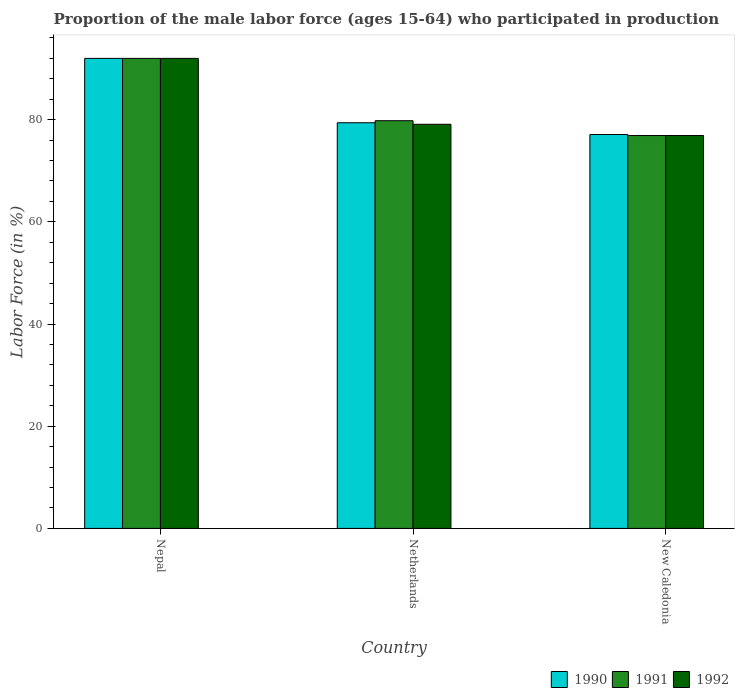What is the label of the 1st group of bars from the left?
Provide a short and direct response. Nepal. What is the proportion of the male labor force who participated in production in 1991 in Netherlands?
Provide a succinct answer. 79.8. Across all countries, what is the maximum proportion of the male labor force who participated in production in 1990?
Provide a succinct answer. 92. Across all countries, what is the minimum proportion of the male labor force who participated in production in 1990?
Provide a short and direct response. 77.1. In which country was the proportion of the male labor force who participated in production in 1991 maximum?
Provide a succinct answer. Nepal. In which country was the proportion of the male labor force who participated in production in 1992 minimum?
Make the answer very short. New Caledonia. What is the total proportion of the male labor force who participated in production in 1991 in the graph?
Ensure brevity in your answer.  248.7. What is the difference between the proportion of the male labor force who participated in production in 1991 in Nepal and that in Netherlands?
Keep it short and to the point. 12.2. What is the difference between the proportion of the male labor force who participated in production in 1992 in Netherlands and the proportion of the male labor force who participated in production in 1991 in New Caledonia?
Your response must be concise. 2.2. What is the average proportion of the male labor force who participated in production in 1992 per country?
Your answer should be very brief. 82.67. What is the difference between the proportion of the male labor force who participated in production of/in 1990 and proportion of the male labor force who participated in production of/in 1991 in Netherlands?
Offer a very short reply. -0.4. What is the ratio of the proportion of the male labor force who participated in production in 1990 in Nepal to that in New Caledonia?
Ensure brevity in your answer.  1.19. Is the proportion of the male labor force who participated in production in 1992 in Nepal less than that in New Caledonia?
Your answer should be compact. No. Is the difference between the proportion of the male labor force who participated in production in 1990 in Netherlands and New Caledonia greater than the difference between the proportion of the male labor force who participated in production in 1991 in Netherlands and New Caledonia?
Provide a succinct answer. No. What is the difference between the highest and the second highest proportion of the male labor force who participated in production in 1990?
Give a very brief answer. 14.9. What is the difference between the highest and the lowest proportion of the male labor force who participated in production in 1992?
Your answer should be compact. 15.1. In how many countries, is the proportion of the male labor force who participated in production in 1992 greater than the average proportion of the male labor force who participated in production in 1992 taken over all countries?
Offer a very short reply. 1. What does the 2nd bar from the left in Netherlands represents?
Provide a succinct answer. 1991. What does the 3rd bar from the right in New Caledonia represents?
Offer a terse response. 1990. Is it the case that in every country, the sum of the proportion of the male labor force who participated in production in 1992 and proportion of the male labor force who participated in production in 1990 is greater than the proportion of the male labor force who participated in production in 1991?
Keep it short and to the point. Yes. Are the values on the major ticks of Y-axis written in scientific E-notation?
Offer a terse response. No. Does the graph contain any zero values?
Provide a succinct answer. No. Where does the legend appear in the graph?
Give a very brief answer. Bottom right. What is the title of the graph?
Your answer should be compact. Proportion of the male labor force (ages 15-64) who participated in production. Does "1991" appear as one of the legend labels in the graph?
Your response must be concise. Yes. What is the label or title of the X-axis?
Your answer should be very brief. Country. What is the Labor Force (in %) of 1990 in Nepal?
Give a very brief answer. 92. What is the Labor Force (in %) of 1991 in Nepal?
Provide a short and direct response. 92. What is the Labor Force (in %) of 1992 in Nepal?
Make the answer very short. 92. What is the Labor Force (in %) in 1990 in Netherlands?
Give a very brief answer. 79.4. What is the Labor Force (in %) in 1991 in Netherlands?
Offer a terse response. 79.8. What is the Labor Force (in %) in 1992 in Netherlands?
Give a very brief answer. 79.1. What is the Labor Force (in %) of 1990 in New Caledonia?
Provide a short and direct response. 77.1. What is the Labor Force (in %) of 1991 in New Caledonia?
Give a very brief answer. 76.9. What is the Labor Force (in %) of 1992 in New Caledonia?
Your answer should be compact. 76.9. Across all countries, what is the maximum Labor Force (in %) of 1990?
Your answer should be compact. 92. Across all countries, what is the maximum Labor Force (in %) of 1991?
Provide a succinct answer. 92. Across all countries, what is the maximum Labor Force (in %) of 1992?
Offer a terse response. 92. Across all countries, what is the minimum Labor Force (in %) in 1990?
Your answer should be very brief. 77.1. Across all countries, what is the minimum Labor Force (in %) in 1991?
Offer a very short reply. 76.9. Across all countries, what is the minimum Labor Force (in %) of 1992?
Offer a very short reply. 76.9. What is the total Labor Force (in %) of 1990 in the graph?
Keep it short and to the point. 248.5. What is the total Labor Force (in %) of 1991 in the graph?
Give a very brief answer. 248.7. What is the total Labor Force (in %) of 1992 in the graph?
Your response must be concise. 248. What is the difference between the Labor Force (in %) in 1990 in Nepal and that in Netherlands?
Provide a succinct answer. 12.6. What is the difference between the Labor Force (in %) in 1991 in Nepal and that in Netherlands?
Your response must be concise. 12.2. What is the difference between the Labor Force (in %) in 1992 in Nepal and that in New Caledonia?
Keep it short and to the point. 15.1. What is the difference between the Labor Force (in %) in 1990 in Netherlands and that in New Caledonia?
Your response must be concise. 2.3. What is the difference between the Labor Force (in %) of 1991 in Netherlands and that in New Caledonia?
Keep it short and to the point. 2.9. What is the difference between the Labor Force (in %) of 1992 in Netherlands and that in New Caledonia?
Provide a succinct answer. 2.2. What is the difference between the Labor Force (in %) of 1990 in Nepal and the Labor Force (in %) of 1991 in Netherlands?
Your answer should be very brief. 12.2. What is the difference between the Labor Force (in %) in 1990 in Nepal and the Labor Force (in %) in 1992 in Netherlands?
Your answer should be compact. 12.9. What is the difference between the Labor Force (in %) of 1991 in Nepal and the Labor Force (in %) of 1992 in Netherlands?
Make the answer very short. 12.9. What is the difference between the Labor Force (in %) of 1990 in Nepal and the Labor Force (in %) of 1991 in New Caledonia?
Your answer should be compact. 15.1. What is the difference between the Labor Force (in %) of 1991 in Nepal and the Labor Force (in %) of 1992 in New Caledonia?
Make the answer very short. 15.1. What is the difference between the Labor Force (in %) in 1990 in Netherlands and the Labor Force (in %) in 1991 in New Caledonia?
Ensure brevity in your answer.  2.5. What is the difference between the Labor Force (in %) of 1990 in Netherlands and the Labor Force (in %) of 1992 in New Caledonia?
Provide a succinct answer. 2.5. What is the average Labor Force (in %) of 1990 per country?
Your answer should be compact. 82.83. What is the average Labor Force (in %) of 1991 per country?
Offer a terse response. 82.9. What is the average Labor Force (in %) of 1992 per country?
Keep it short and to the point. 82.67. What is the difference between the Labor Force (in %) of 1991 and Labor Force (in %) of 1992 in Nepal?
Your response must be concise. 0. What is the difference between the Labor Force (in %) in 1990 and Labor Force (in %) in 1991 in Netherlands?
Provide a succinct answer. -0.4. What is the difference between the Labor Force (in %) in 1990 and Labor Force (in %) in 1992 in Netherlands?
Make the answer very short. 0.3. What is the difference between the Labor Force (in %) in 1990 and Labor Force (in %) in 1992 in New Caledonia?
Offer a terse response. 0.2. What is the difference between the Labor Force (in %) in 1991 and Labor Force (in %) in 1992 in New Caledonia?
Provide a short and direct response. 0. What is the ratio of the Labor Force (in %) in 1990 in Nepal to that in Netherlands?
Offer a terse response. 1.16. What is the ratio of the Labor Force (in %) of 1991 in Nepal to that in Netherlands?
Offer a very short reply. 1.15. What is the ratio of the Labor Force (in %) in 1992 in Nepal to that in Netherlands?
Your answer should be compact. 1.16. What is the ratio of the Labor Force (in %) in 1990 in Nepal to that in New Caledonia?
Give a very brief answer. 1.19. What is the ratio of the Labor Force (in %) in 1991 in Nepal to that in New Caledonia?
Provide a succinct answer. 1.2. What is the ratio of the Labor Force (in %) of 1992 in Nepal to that in New Caledonia?
Keep it short and to the point. 1.2. What is the ratio of the Labor Force (in %) in 1990 in Netherlands to that in New Caledonia?
Ensure brevity in your answer.  1.03. What is the ratio of the Labor Force (in %) of 1991 in Netherlands to that in New Caledonia?
Your answer should be very brief. 1.04. What is the ratio of the Labor Force (in %) in 1992 in Netherlands to that in New Caledonia?
Offer a very short reply. 1.03. What is the difference between the highest and the second highest Labor Force (in %) of 1991?
Provide a short and direct response. 12.2. What is the difference between the highest and the lowest Labor Force (in %) of 1990?
Make the answer very short. 14.9. 